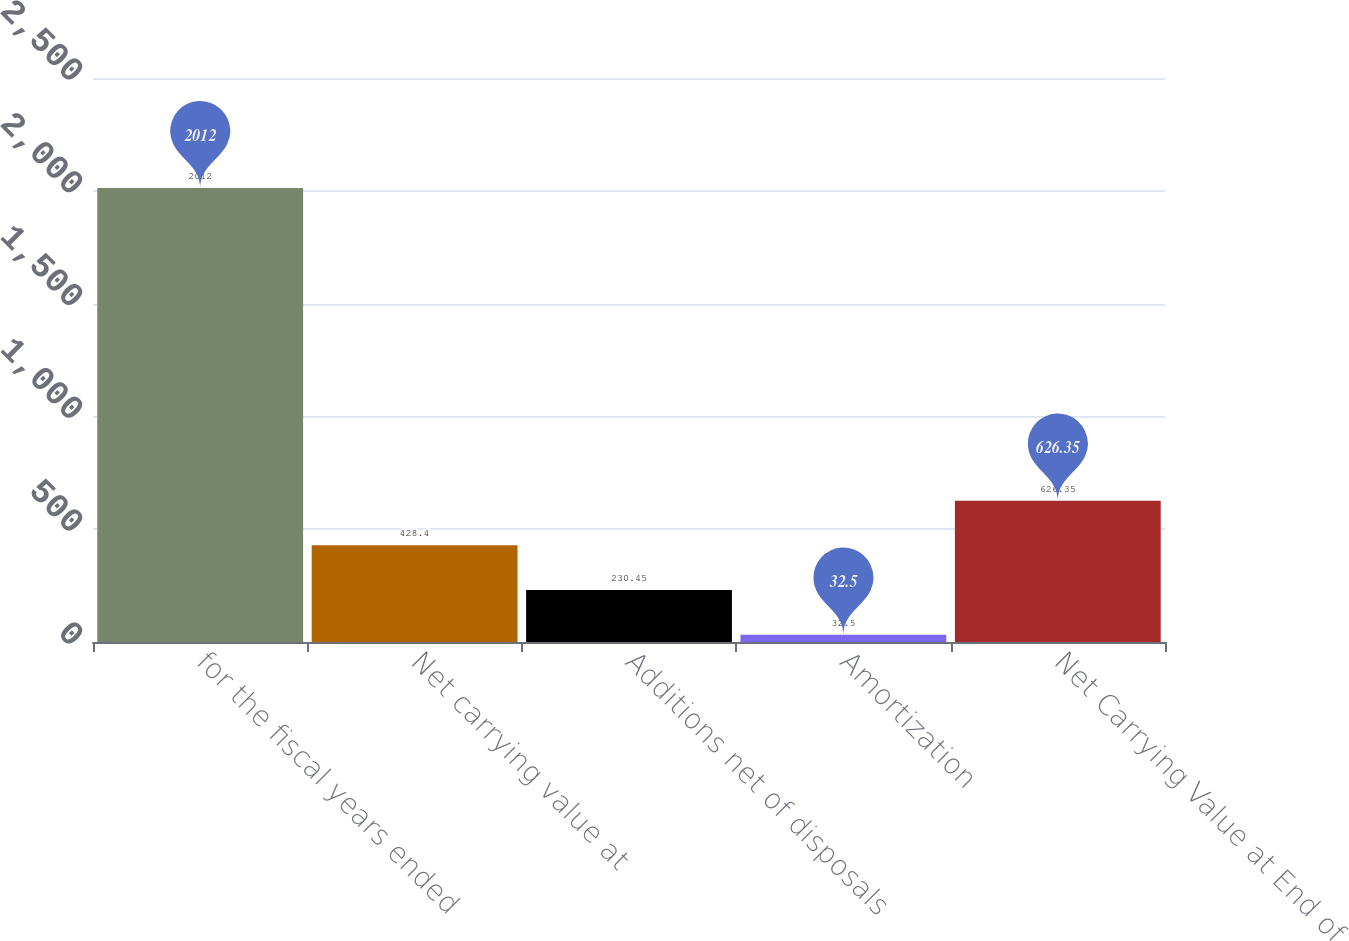<chart> <loc_0><loc_0><loc_500><loc_500><bar_chart><fcel>for the fiscal years ended<fcel>Net carrying value at<fcel>Additions net of disposals<fcel>Amortization<fcel>Net Carrying Value at End of<nl><fcel>2012<fcel>428.4<fcel>230.45<fcel>32.5<fcel>626.35<nl></chart> 